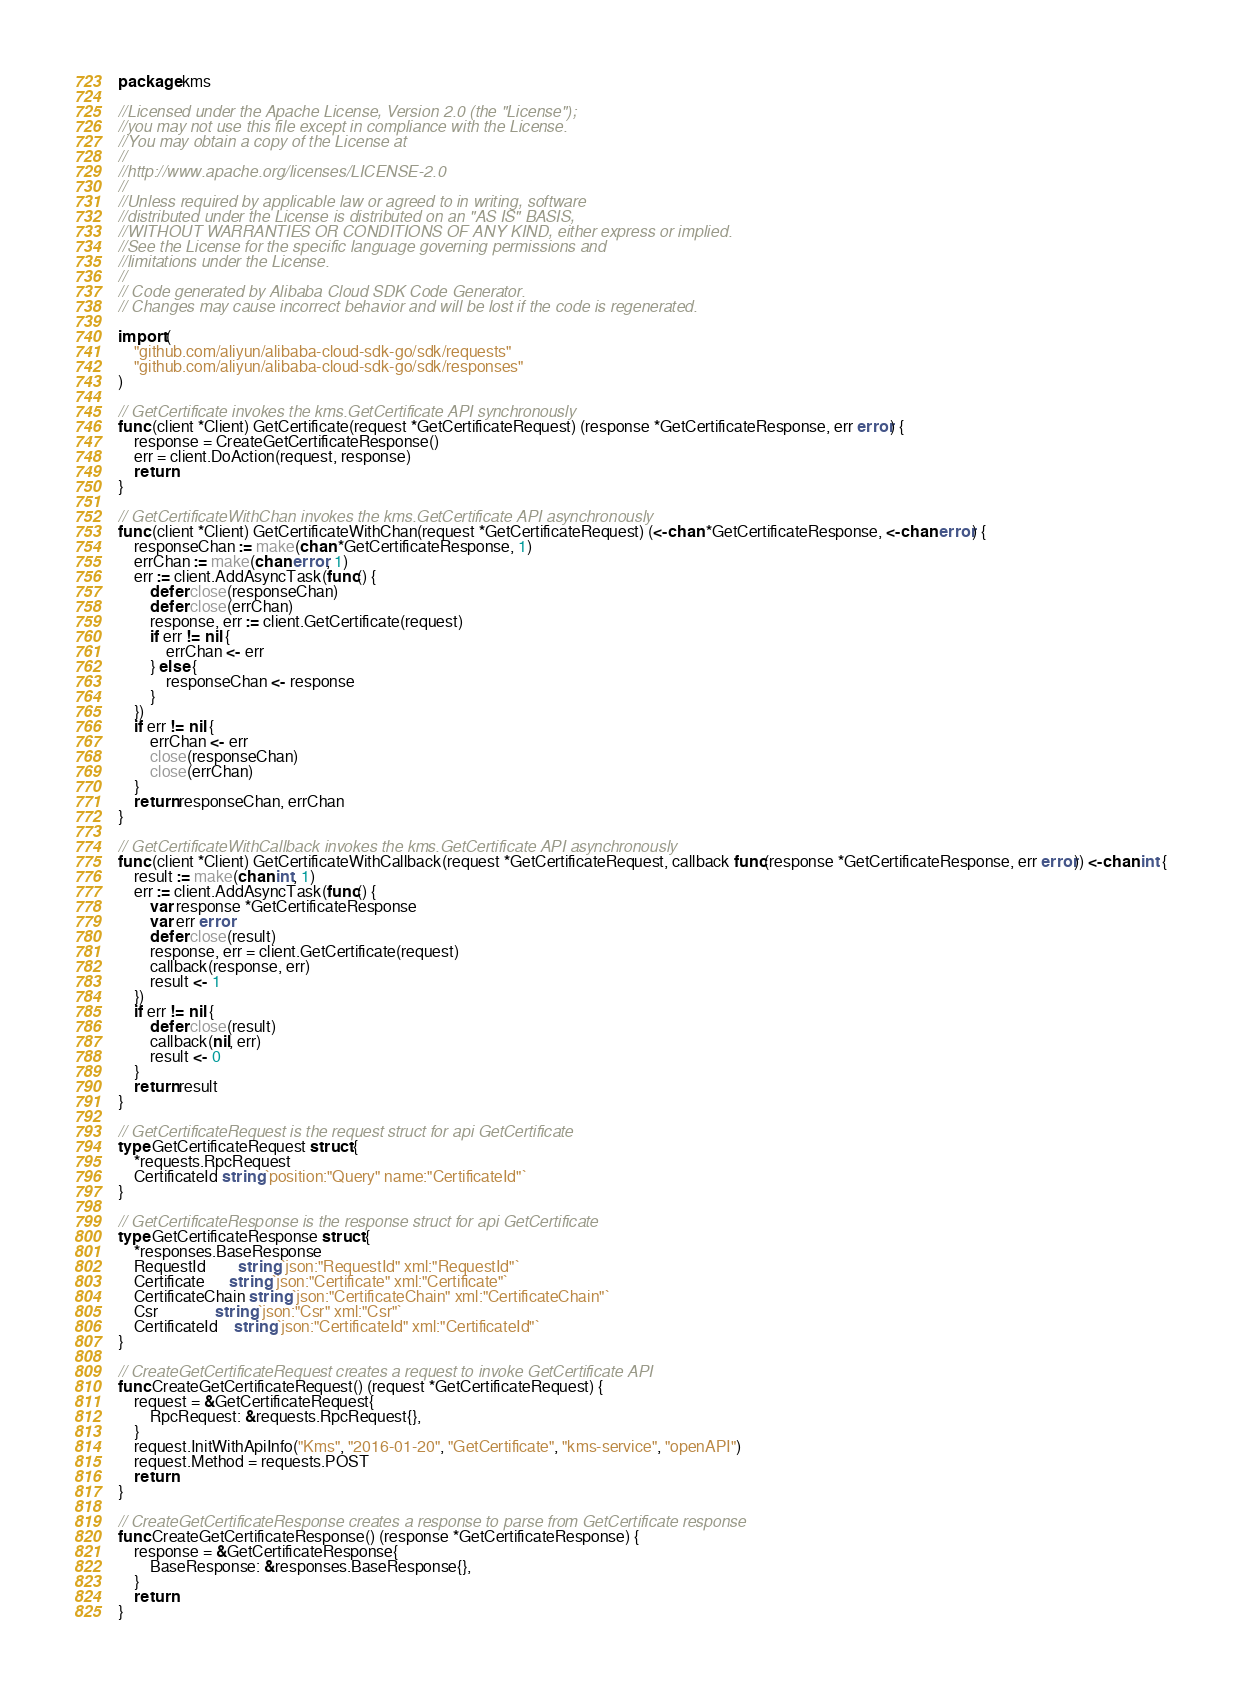Convert code to text. <code><loc_0><loc_0><loc_500><loc_500><_Go_>package kms

//Licensed under the Apache License, Version 2.0 (the "License");
//you may not use this file except in compliance with the License.
//You may obtain a copy of the License at
//
//http://www.apache.org/licenses/LICENSE-2.0
//
//Unless required by applicable law or agreed to in writing, software
//distributed under the License is distributed on an "AS IS" BASIS,
//WITHOUT WARRANTIES OR CONDITIONS OF ANY KIND, either express or implied.
//See the License for the specific language governing permissions and
//limitations under the License.
//
// Code generated by Alibaba Cloud SDK Code Generator.
// Changes may cause incorrect behavior and will be lost if the code is regenerated.

import (
	"github.com/aliyun/alibaba-cloud-sdk-go/sdk/requests"
	"github.com/aliyun/alibaba-cloud-sdk-go/sdk/responses"
)

// GetCertificate invokes the kms.GetCertificate API synchronously
func (client *Client) GetCertificate(request *GetCertificateRequest) (response *GetCertificateResponse, err error) {
	response = CreateGetCertificateResponse()
	err = client.DoAction(request, response)
	return
}

// GetCertificateWithChan invokes the kms.GetCertificate API asynchronously
func (client *Client) GetCertificateWithChan(request *GetCertificateRequest) (<-chan *GetCertificateResponse, <-chan error) {
	responseChan := make(chan *GetCertificateResponse, 1)
	errChan := make(chan error, 1)
	err := client.AddAsyncTask(func() {
		defer close(responseChan)
		defer close(errChan)
		response, err := client.GetCertificate(request)
		if err != nil {
			errChan <- err
		} else {
			responseChan <- response
		}
	})
	if err != nil {
		errChan <- err
		close(responseChan)
		close(errChan)
	}
	return responseChan, errChan
}

// GetCertificateWithCallback invokes the kms.GetCertificate API asynchronously
func (client *Client) GetCertificateWithCallback(request *GetCertificateRequest, callback func(response *GetCertificateResponse, err error)) <-chan int {
	result := make(chan int, 1)
	err := client.AddAsyncTask(func() {
		var response *GetCertificateResponse
		var err error
		defer close(result)
		response, err = client.GetCertificate(request)
		callback(response, err)
		result <- 1
	})
	if err != nil {
		defer close(result)
		callback(nil, err)
		result <- 0
	}
	return result
}

// GetCertificateRequest is the request struct for api GetCertificate
type GetCertificateRequest struct {
	*requests.RpcRequest
	CertificateId string `position:"Query" name:"CertificateId"`
}

// GetCertificateResponse is the response struct for api GetCertificate
type GetCertificateResponse struct {
	*responses.BaseResponse
	RequestId        string `json:"RequestId" xml:"RequestId"`
	Certificate      string `json:"Certificate" xml:"Certificate"`
	CertificateChain string `json:"CertificateChain" xml:"CertificateChain"`
	Csr              string `json:"Csr" xml:"Csr"`
	CertificateId    string `json:"CertificateId" xml:"CertificateId"`
}

// CreateGetCertificateRequest creates a request to invoke GetCertificate API
func CreateGetCertificateRequest() (request *GetCertificateRequest) {
	request = &GetCertificateRequest{
		RpcRequest: &requests.RpcRequest{},
	}
	request.InitWithApiInfo("Kms", "2016-01-20", "GetCertificate", "kms-service", "openAPI")
	request.Method = requests.POST
	return
}

// CreateGetCertificateResponse creates a response to parse from GetCertificate response
func CreateGetCertificateResponse() (response *GetCertificateResponse) {
	response = &GetCertificateResponse{
		BaseResponse: &responses.BaseResponse{},
	}
	return
}
</code> 